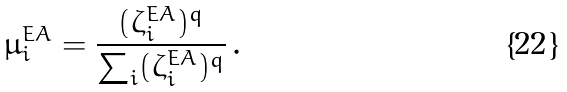<formula> <loc_0><loc_0><loc_500><loc_500>\mu _ { i } ^ { E A } = \frac { ( \zeta _ { i } ^ { E A } ) ^ { q } } { \sum _ { i } ( \zeta _ { i } ^ { E A } ) ^ { q } } \, .</formula> 